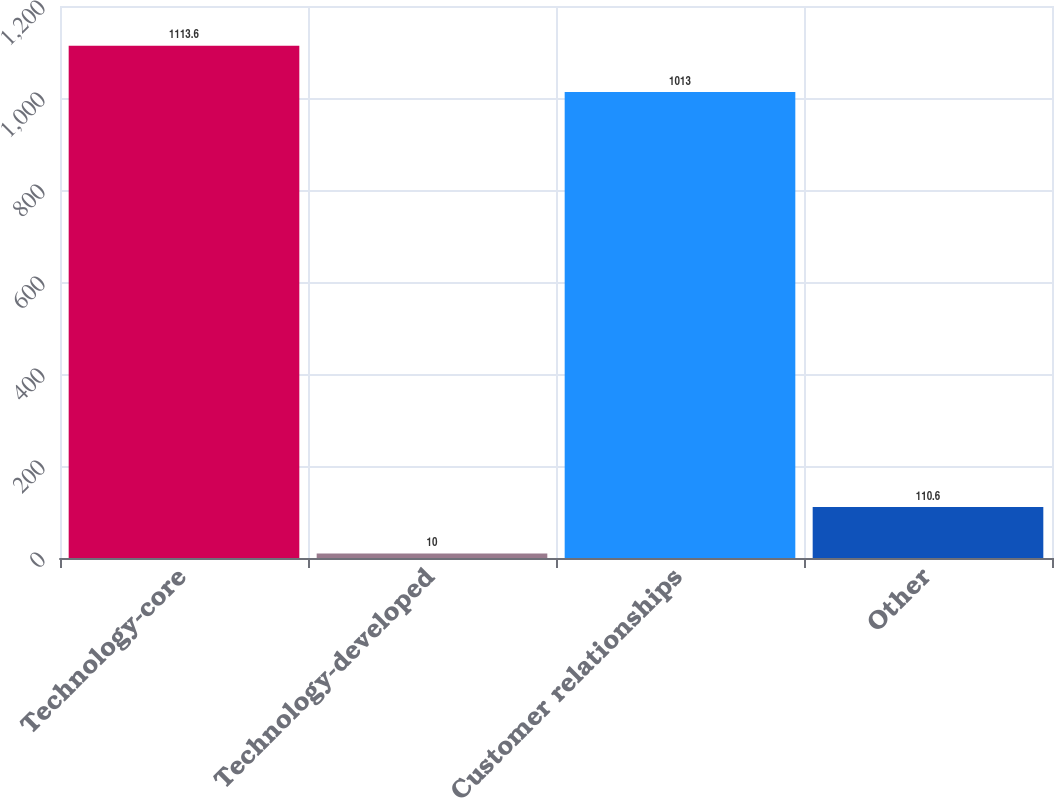Convert chart. <chart><loc_0><loc_0><loc_500><loc_500><bar_chart><fcel>Technology-core<fcel>Technology-developed<fcel>Customer relationships<fcel>Other<nl><fcel>1113.6<fcel>10<fcel>1013<fcel>110.6<nl></chart> 